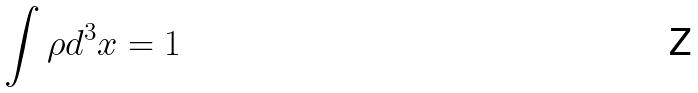<formula> <loc_0><loc_0><loc_500><loc_500>\int \rho d ^ { 3 } x = 1</formula> 